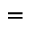<formula> <loc_0><loc_0><loc_500><loc_500>=</formula> 